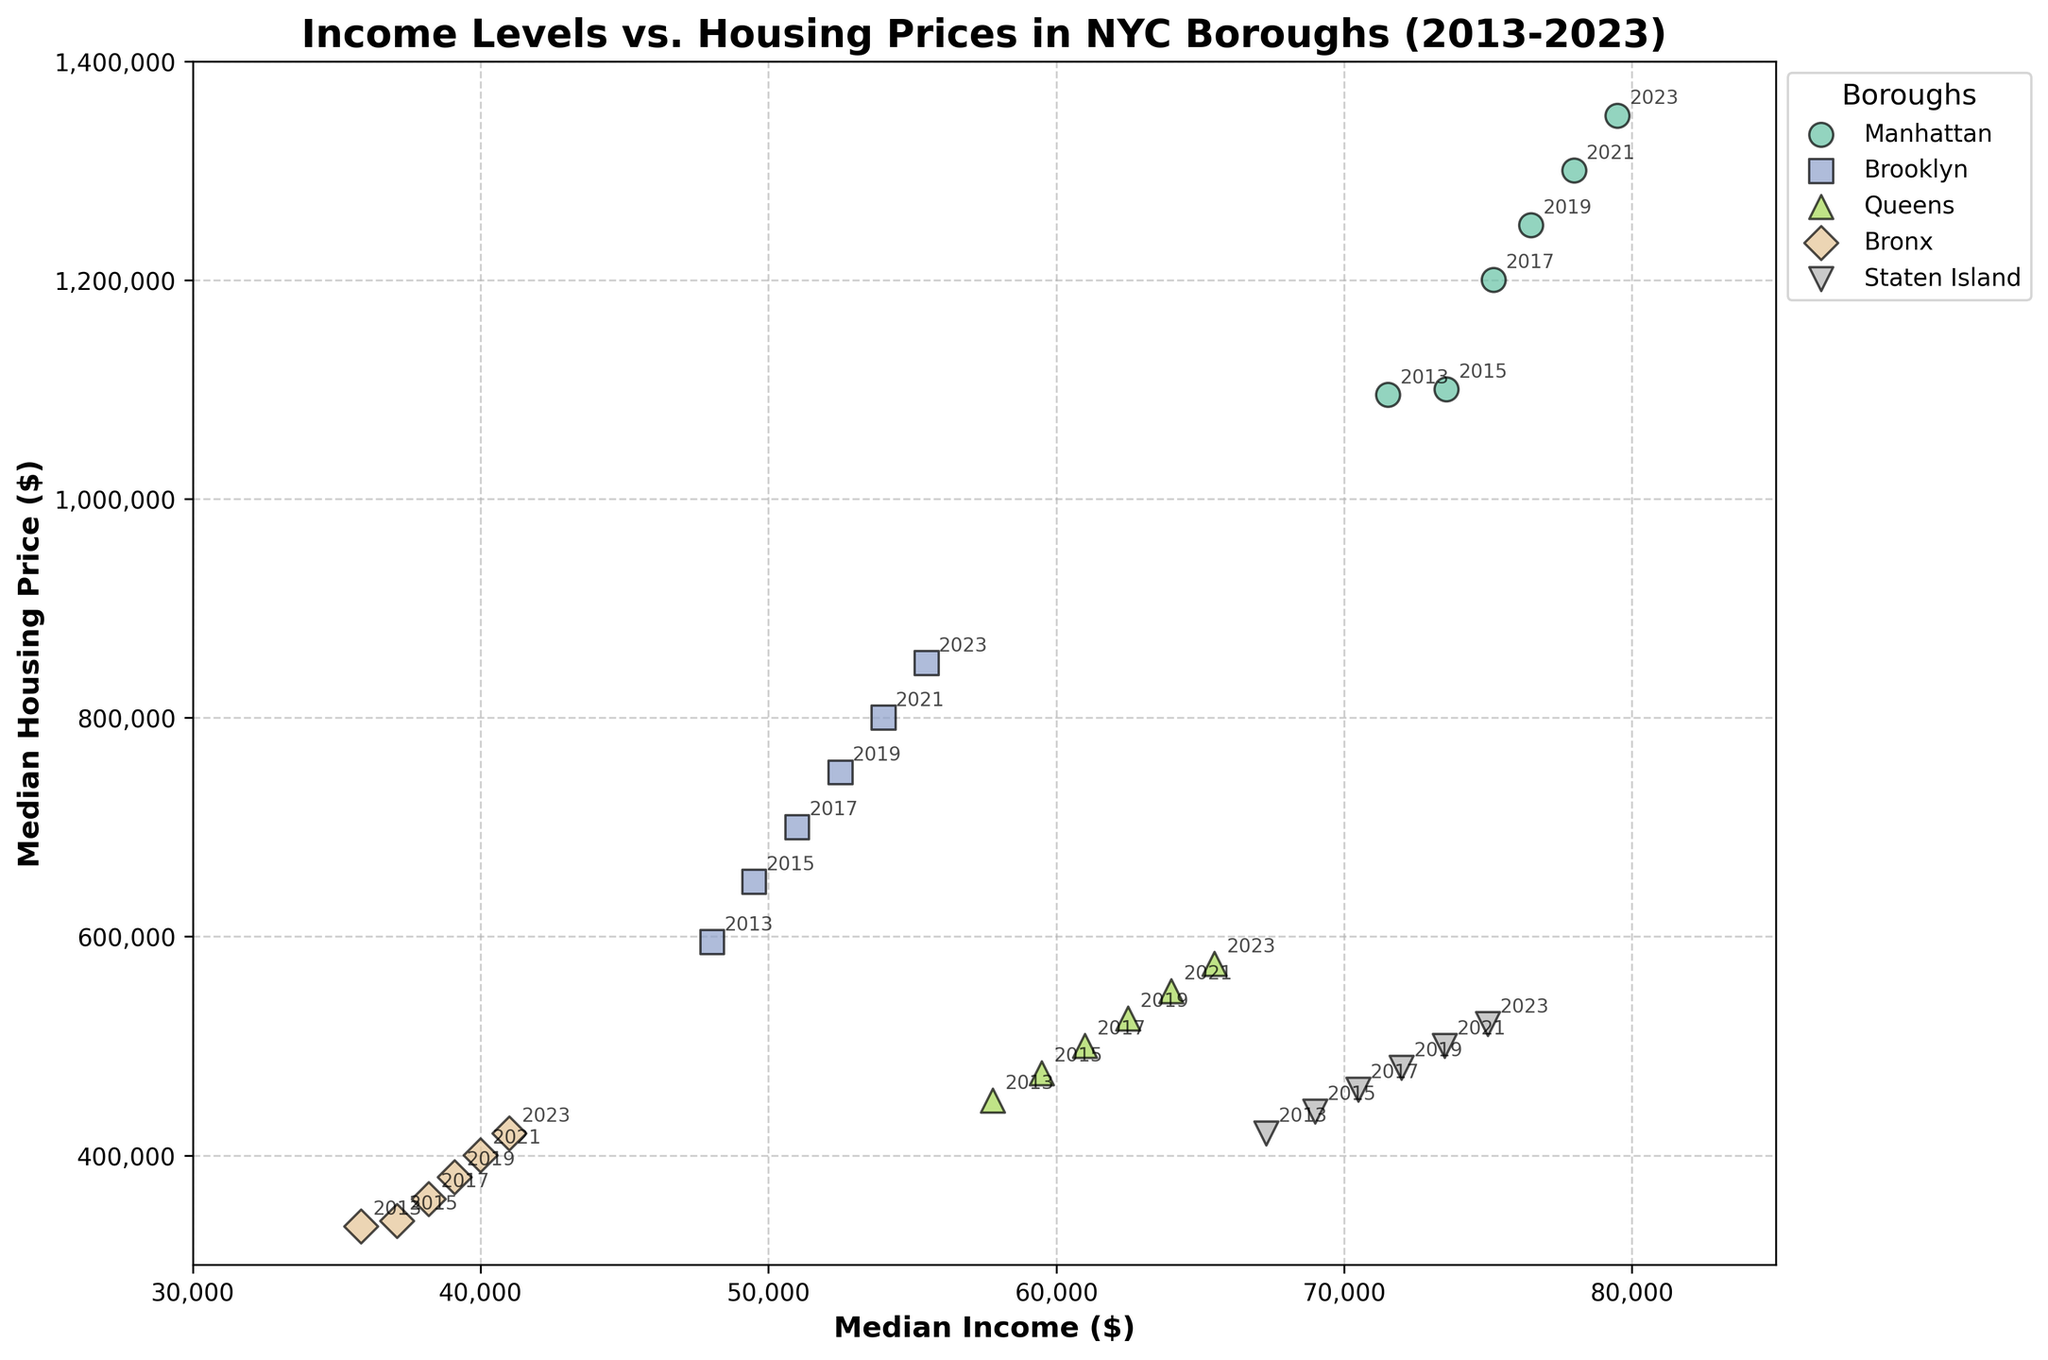What's the title of the figure? Look at the top of the figure where the title is usually placed. The title of this figure is clearly stated there.
Answer: Income Levels vs. Housing Prices in NYC Boroughs (2013-2023) What's the range of the x-axis? The x-axis represents the Median Income, and by observing the axis limits, we can see the range.
Answer: 30000 to 85000 Which borough had the highest median housing price in 2023? Look for the data points labeled "2023" and identify the borough with the highest y-axis value.
Answer: Manhattan How does the median income in the Bronx in 2023 compare to that in 2015? Locate the data points for the Bronx for the years 2015 and 2023. Check the x-axis values for these points and compare them.
Answer: Higher in 2023 What trend do you see in Manhattan's median housing prices from 2013 to 2023? Observe the y-axis values for Manhattan over the years 2013, 2015, 2017, 2019, 2021, and 2023. Note the change in values across these years.
Answer: Increasing Which borough had the smallest increase in median income from 2013 to 2023? For each borough, find the median income values for 2013 and 2023. Calculate the increases and compare them to identify the smallest.
Answer: Bronx In which year did Brooklyn's median housing price first exceed $600,000? Observe Brooklyn's data points and pinpoint the year when the y-axis value crosses $600,000.
Answer: 2015 Is there a correlation between income levels and housing prices in Queens? Assess the scatter plot for Queens by observing how the x-axis (income) and y-axis (housing prices) data points relate.
Answer: Yes, positive correlation Compare the median housing prices in Staten Island in 2013 and 2023. Locate Staten Island's data points for 2013 and 2023. Check and compare their y-axis values.
Answer: Higher in 2023 Which borough's data points appear the most clustered together in the plot? Assess the overall scatter of data points for each borough and identify which set shows the least dispersion.
Answer: Queens 